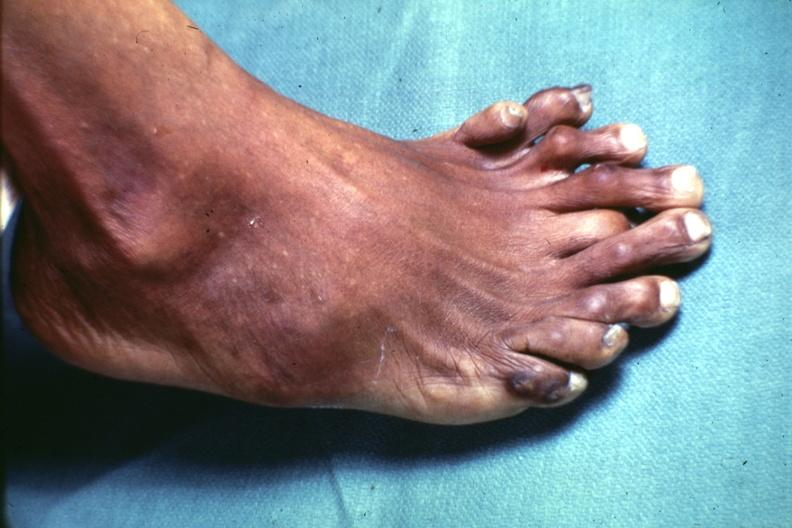how many toes does this image show view from dorsum of foot which has at least?
Answer the question using a single word or phrase. 9 